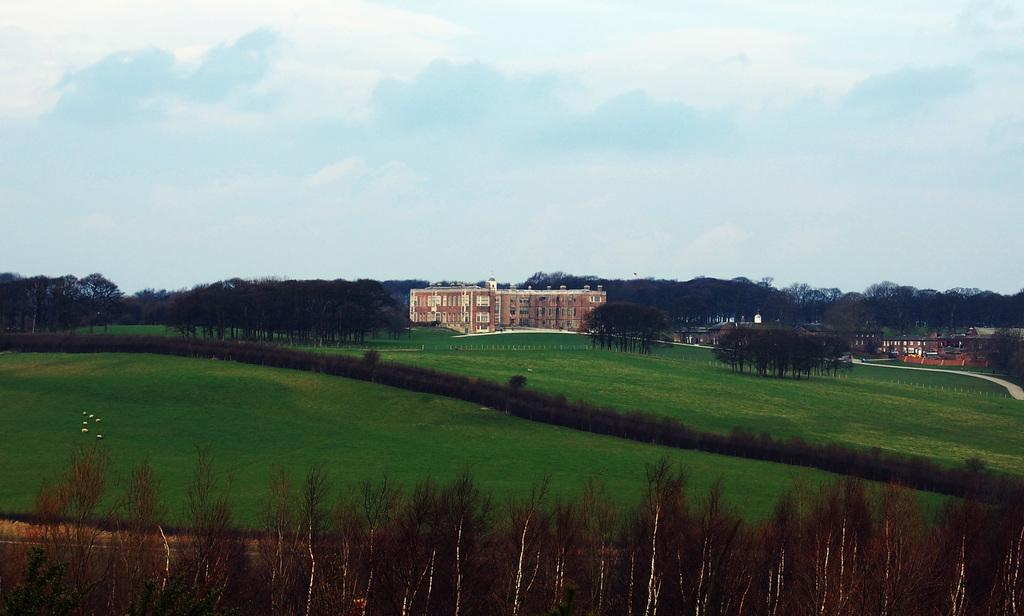What is the main subject in the center of the image? There is a building in the center of the image. What type of vegetation can be seen at the bottom of the image? Grass and plants are visible at the bottom of the image. What can be seen in the background of the image? Trees, the sky, and clouds are visible in the background of the image. How many eggs are being delivered by the ladybug in the image? There is no ladybug or eggs present in the image. What news is being reported by the news anchor in the image? There is no news anchor or news report present in the image. 